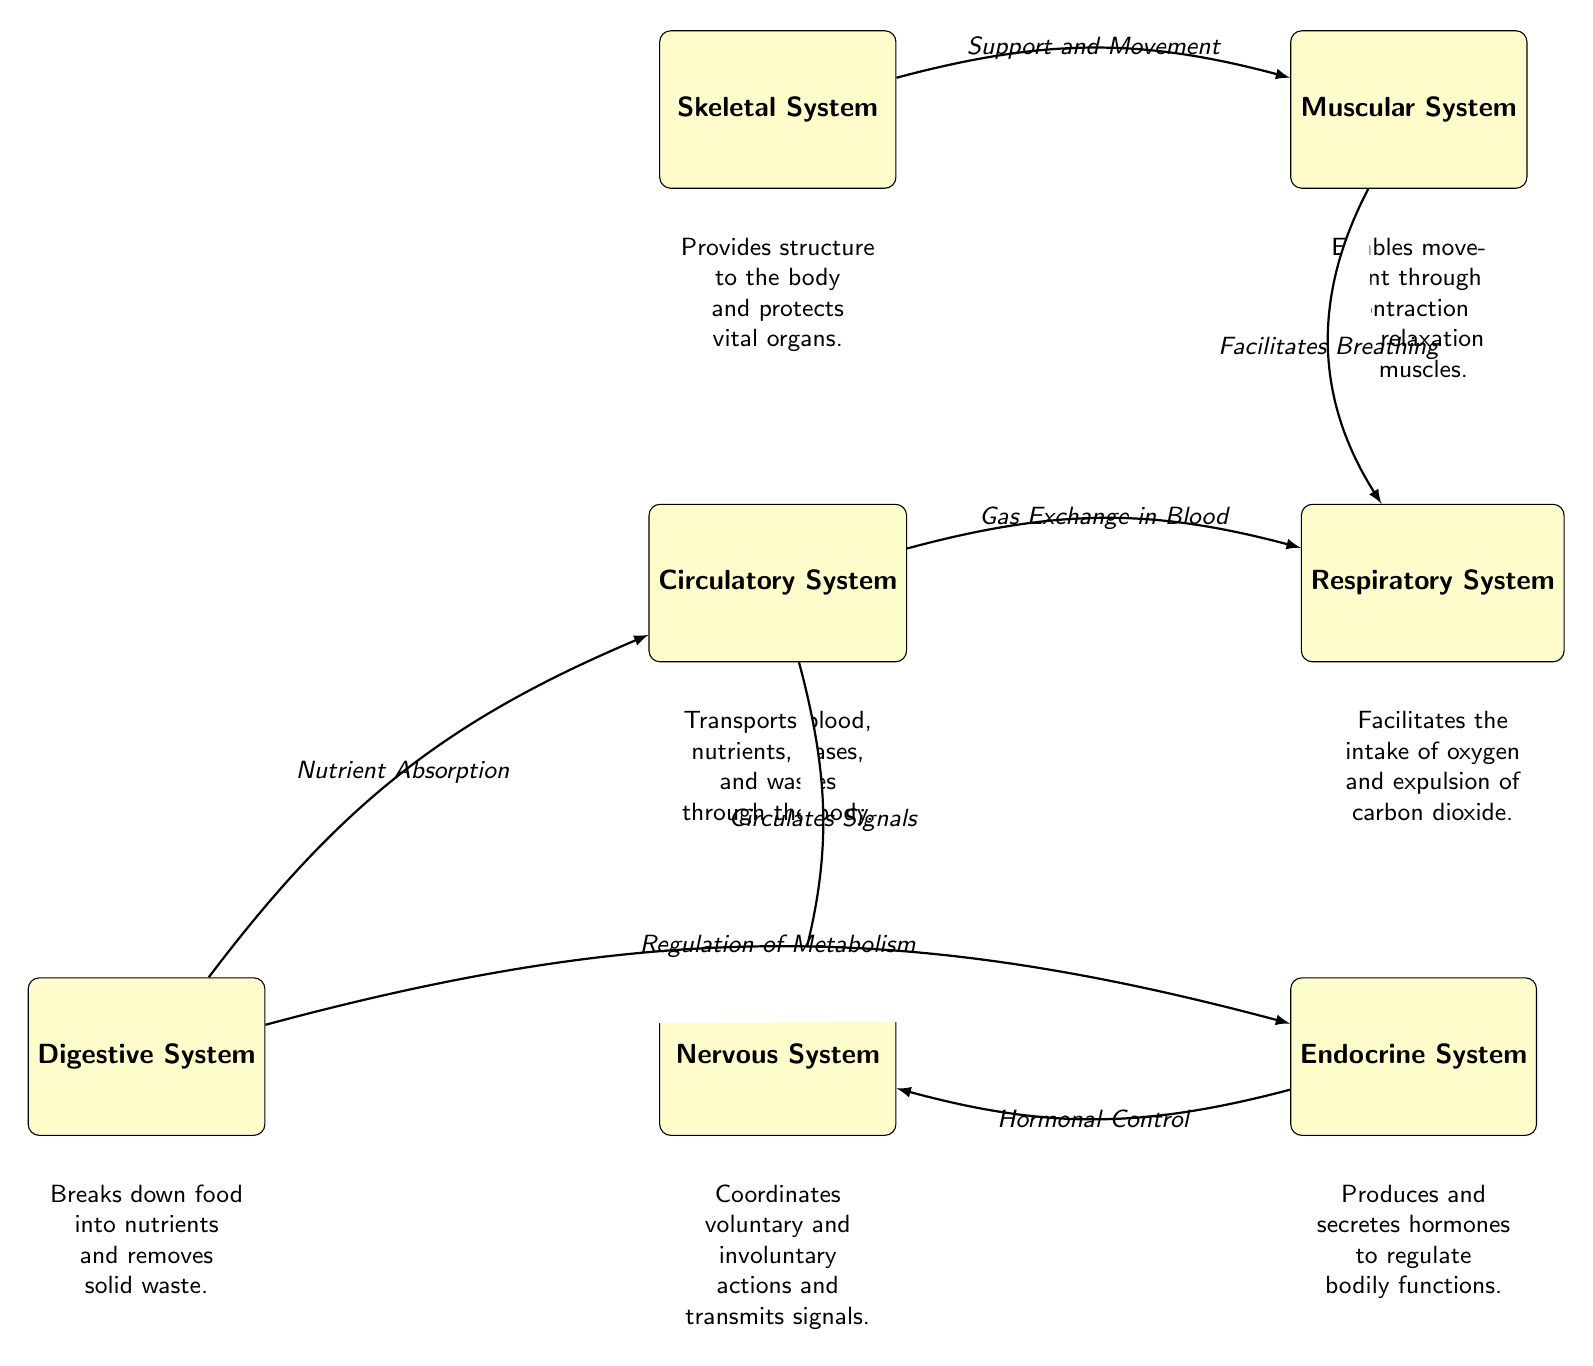What are the six major systems depicted in the diagram? The diagram outlines the Skeletal, Muscular, Circulatory, Respiratory, Nervous, and Digestive systems as the major systems.
Answer: Skeletal, Muscular, Circulatory, Respiratory, Nervous, Digestive What system is responsible for the intake of oxygen? The description under the Respiratory System states that it facilitates the intake of oxygen and the expulsion of carbon dioxide.
Answer: Respiratory System Which system produces hormones? The description under the Endocrine System indicates that it produces and secretes hormones to regulate bodily functions.
Answer: Endocrine System How many systems are connected to the Circulatory System? The Circulatory System connects to three other systems: Respiratory, Nervous, and Digestive. Therefore, the answer is based on counting the connections.
Answer: 3 What facilitates breathing in the diagram? The connection between the Muscular and Respiratory systems describes the role of the Muscular System in facilitating breathing.
Answer: Muscular System What is the function of the Nervous System as per the diagram? According to the description, the Nervous System coordinates voluntary and involuntary actions and transmits signals.
Answer: Coordinates voluntary and involuntary actions Which two systems are linked by the nutrient absorption process? The diagram indicates that the Digestive System links to the Circulatory System through the process of Nutrient Absorption.
Answer: Digestive System and Circulatory System Which system protects vital organs? The Skeletal System's description states that it provides structure and protects vital organs.
Answer: Skeletal System What is the connection between the Endocrine and Nervous systems? The diagram shows that the Endocrine System connects to the Nervous System with the edge labeled "Hormonal Control."
Answer: Hormonal Control 